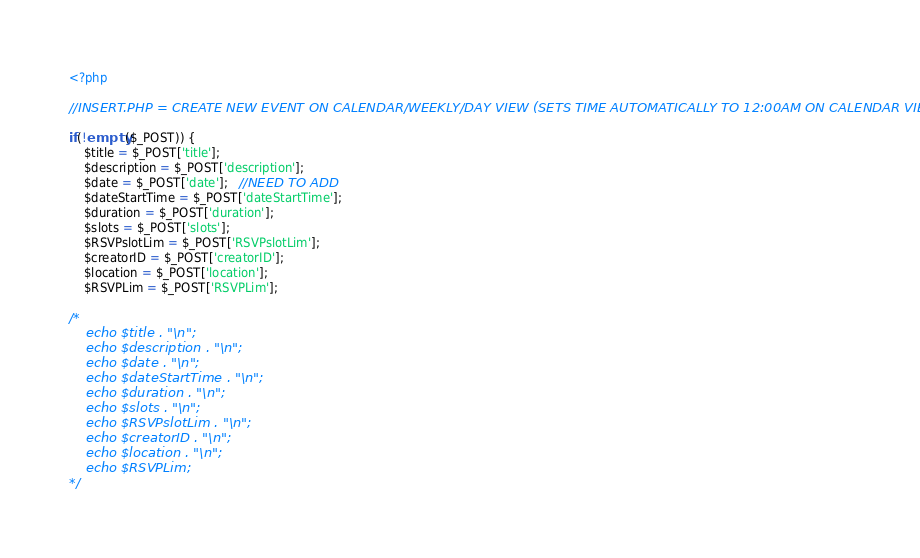<code> <loc_0><loc_0><loc_500><loc_500><_PHP_>
<?php

//INSERT.PHP = CREATE NEW EVENT ON CALENDAR/WEEKLY/DAY VIEW (SETS TIME AUTOMATICALLY TO 12:00AM ON CALENDAR VIEW)

if(!empty($_POST)) {
    $title = $_POST['title'];
    $description = $_POST['description'];
    $date = $_POST['date'];   //NEED TO ADD
    $dateStartTime = $_POST['dateStartTime'];
    $duration = $_POST['duration'];
    $slots = $_POST['slots'];
    $RSVPslotLim = $_POST['RSVPslotLim'];
    $creatorID = $_POST['creatorID'];
    $location = $_POST['location'];
    $RSVPLim = $_POST['RSVPLim'];

/*
    echo $title . "\n";
    echo $description . "\n";
    echo $date . "\n";
    echo $dateStartTime . "\n";
    echo $duration . "\n";
    echo $slots . "\n";
    echo $RSVPslotLim . "\n";
    echo $creatorID . "\n";
    echo $location . "\n";
    echo $RSVPLim;
*/

</code> 